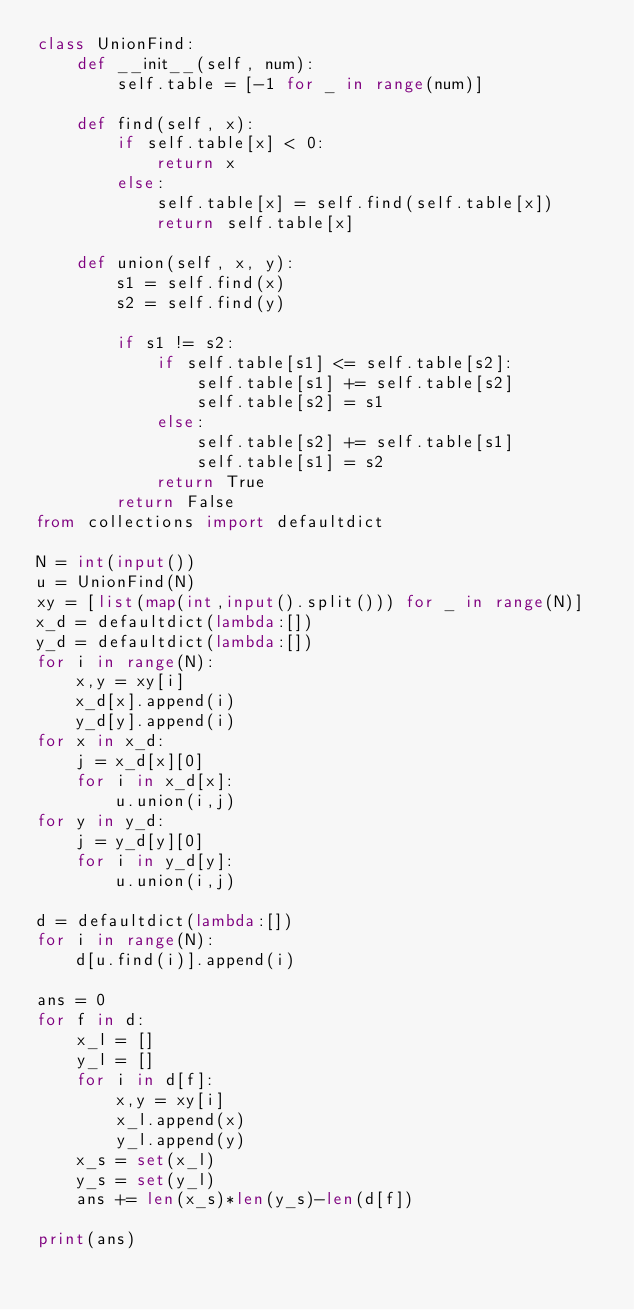<code> <loc_0><loc_0><loc_500><loc_500><_Python_>class UnionFind:
    def __init__(self, num):
        self.table = [-1 for _ in range(num)]

    def find(self, x):
        if self.table[x] < 0:
            return x
        else:
            self.table[x] = self.find(self.table[x])
            return self.table[x]

    def union(self, x, y):
        s1 = self.find(x)
        s2 = self.find(y)

        if s1 != s2:
            if self.table[s1] <= self.table[s2]:
                self.table[s1] += self.table[s2]
                self.table[s2] = s1
            else:
                self.table[s2] += self.table[s1]
                self.table[s1] = s2
            return True
        return False
from collections import defaultdict

N = int(input())
u = UnionFind(N)
xy = [list(map(int,input().split())) for _ in range(N)]
x_d = defaultdict(lambda:[])
y_d = defaultdict(lambda:[])
for i in range(N):
    x,y = xy[i]
    x_d[x].append(i)
    y_d[y].append(i)
for x in x_d:
    j = x_d[x][0]
    for i in x_d[x]:
        u.union(i,j)
for y in y_d:
    j = y_d[y][0]
    for i in y_d[y]:
        u.union(i,j)

d = defaultdict(lambda:[])
for i in range(N):
    d[u.find(i)].append(i)

ans = 0
for f in d:
    x_l = []
    y_l = []
    for i in d[f]:
        x,y = xy[i]
        x_l.append(x)
        y_l.append(y)
    x_s = set(x_l)
    y_s = set(y_l)
    ans += len(x_s)*len(y_s)-len(d[f])

print(ans)</code> 